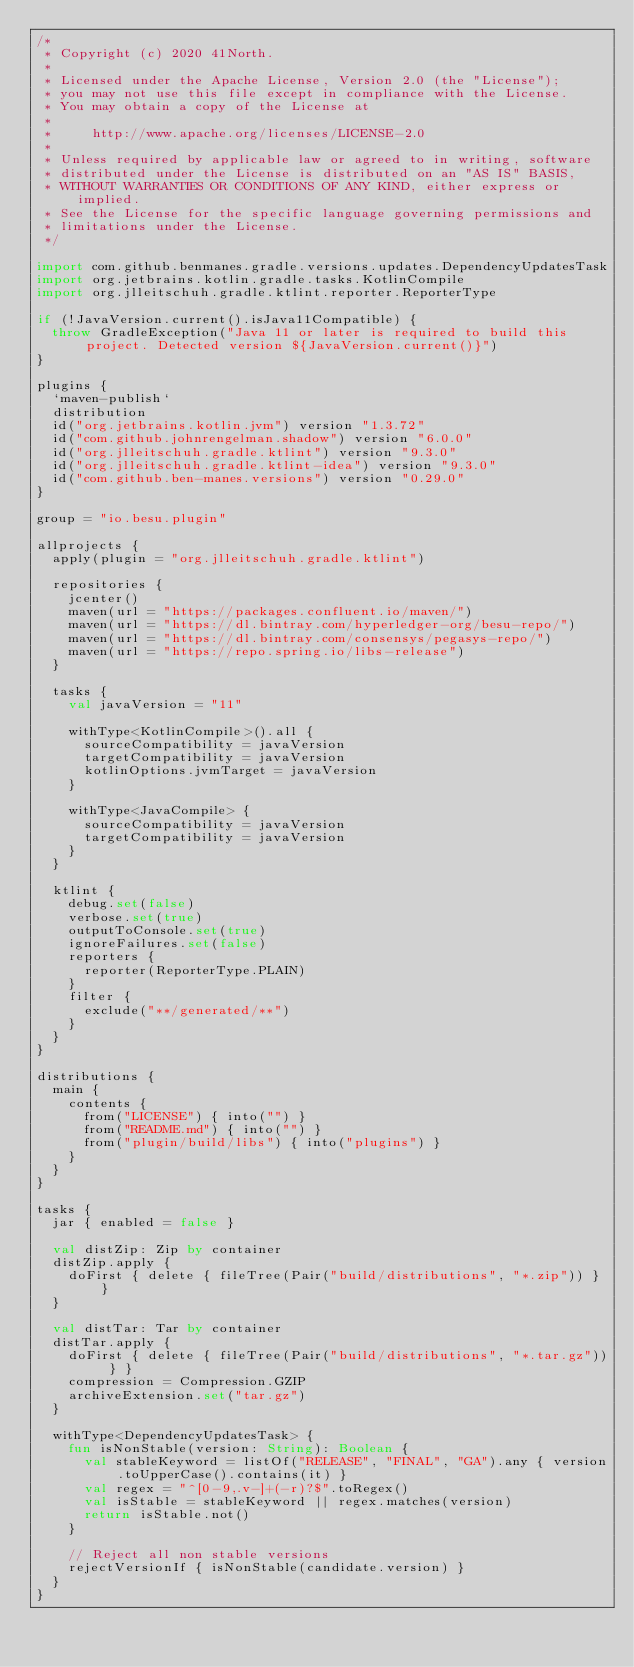Convert code to text. <code><loc_0><loc_0><loc_500><loc_500><_Kotlin_>/*
 * Copyright (c) 2020 41North.
 *
 * Licensed under the Apache License, Version 2.0 (the "License");
 * you may not use this file except in compliance with the License.
 * You may obtain a copy of the License at
 *
 *     http://www.apache.org/licenses/LICENSE-2.0
 *
 * Unless required by applicable law or agreed to in writing, software
 * distributed under the License is distributed on an "AS IS" BASIS,
 * WITHOUT WARRANTIES OR CONDITIONS OF ANY KIND, either express or implied.
 * See the License for the specific language governing permissions and
 * limitations under the License.
 */

import com.github.benmanes.gradle.versions.updates.DependencyUpdatesTask
import org.jetbrains.kotlin.gradle.tasks.KotlinCompile
import org.jlleitschuh.gradle.ktlint.reporter.ReporterType

if (!JavaVersion.current().isJava11Compatible) {
  throw GradleException("Java 11 or later is required to build this project. Detected version ${JavaVersion.current()}")
}

plugins {
  `maven-publish`
  distribution
  id("org.jetbrains.kotlin.jvm") version "1.3.72"
  id("com.github.johnrengelman.shadow") version "6.0.0"
  id("org.jlleitschuh.gradle.ktlint") version "9.3.0"
  id("org.jlleitschuh.gradle.ktlint-idea") version "9.3.0"
  id("com.github.ben-manes.versions") version "0.29.0"
}

group = "io.besu.plugin"

allprojects {
  apply(plugin = "org.jlleitschuh.gradle.ktlint")

  repositories {
    jcenter()
    maven(url = "https://packages.confluent.io/maven/")
    maven(url = "https://dl.bintray.com/hyperledger-org/besu-repo/")
    maven(url = "https://dl.bintray.com/consensys/pegasys-repo/")
    maven(url = "https://repo.spring.io/libs-release")
  }

  tasks {
    val javaVersion = "11"

    withType<KotlinCompile>().all {
      sourceCompatibility = javaVersion
      targetCompatibility = javaVersion
      kotlinOptions.jvmTarget = javaVersion
    }

    withType<JavaCompile> {
      sourceCompatibility = javaVersion
      targetCompatibility = javaVersion
    }
  }

  ktlint {
    debug.set(false)
    verbose.set(true)
    outputToConsole.set(true)
    ignoreFailures.set(false)
    reporters {
      reporter(ReporterType.PLAIN)
    }
    filter {
      exclude("**/generated/**")
    }
  }
}

distributions {
  main {
    contents {
      from("LICENSE") { into("") }
      from("README.md") { into("") }
      from("plugin/build/libs") { into("plugins") }
    }
  }
}

tasks {
  jar { enabled = false }

  val distZip: Zip by container
  distZip.apply {
    doFirst { delete { fileTree(Pair("build/distributions", "*.zip")) } }
  }

  val distTar: Tar by container
  distTar.apply {
    doFirst { delete { fileTree(Pair("build/distributions", "*.tar.gz")) } }
    compression = Compression.GZIP
    archiveExtension.set("tar.gz")
  }

  withType<DependencyUpdatesTask> {
    fun isNonStable(version: String): Boolean {
      val stableKeyword = listOf("RELEASE", "FINAL", "GA").any { version.toUpperCase().contains(it) }
      val regex = "^[0-9,.v-]+(-r)?$".toRegex()
      val isStable = stableKeyword || regex.matches(version)
      return isStable.not()
    }

    // Reject all non stable versions
    rejectVersionIf { isNonStable(candidate.version) }
  }
}
</code> 